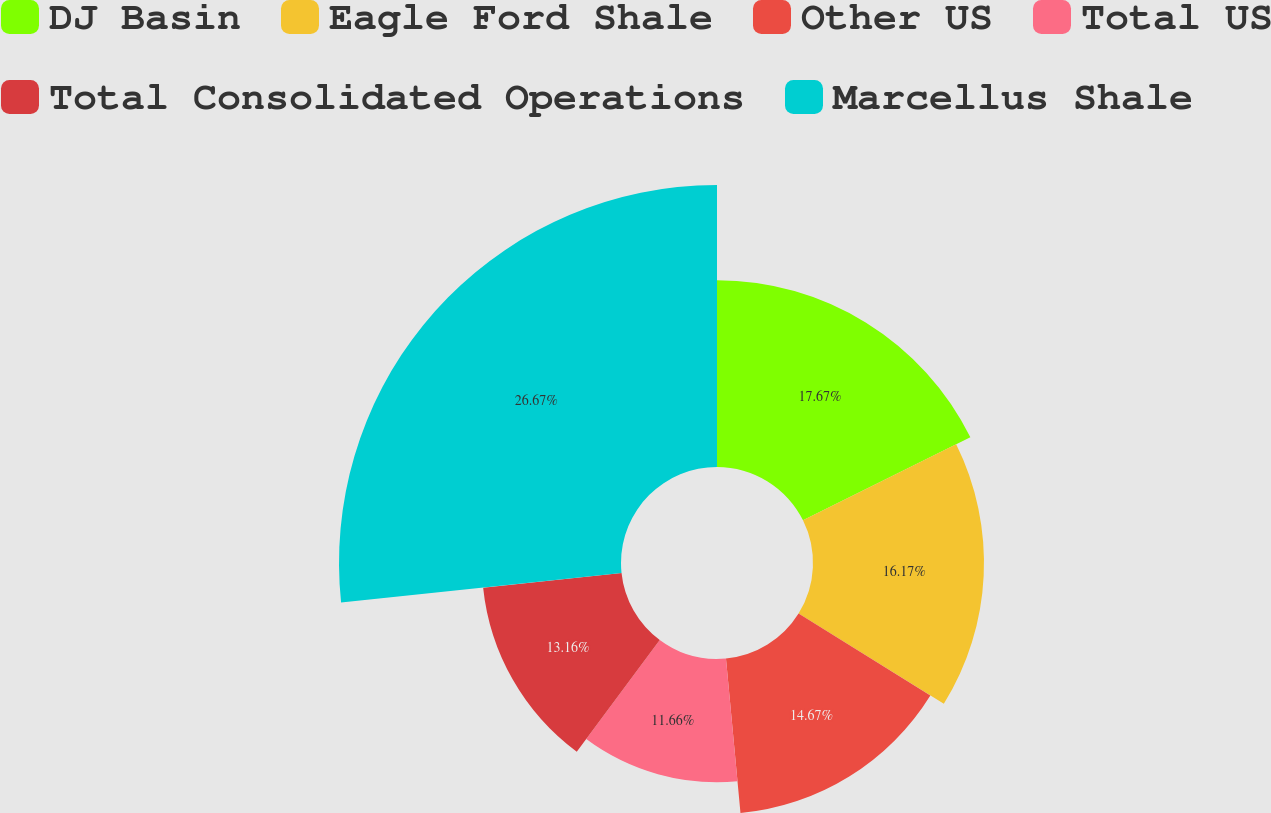Convert chart to OTSL. <chart><loc_0><loc_0><loc_500><loc_500><pie_chart><fcel>DJ Basin<fcel>Eagle Ford Shale<fcel>Other US<fcel>Total US<fcel>Total Consolidated Operations<fcel>Marcellus Shale<nl><fcel>17.67%<fcel>16.17%<fcel>14.67%<fcel>11.66%<fcel>13.16%<fcel>26.67%<nl></chart> 